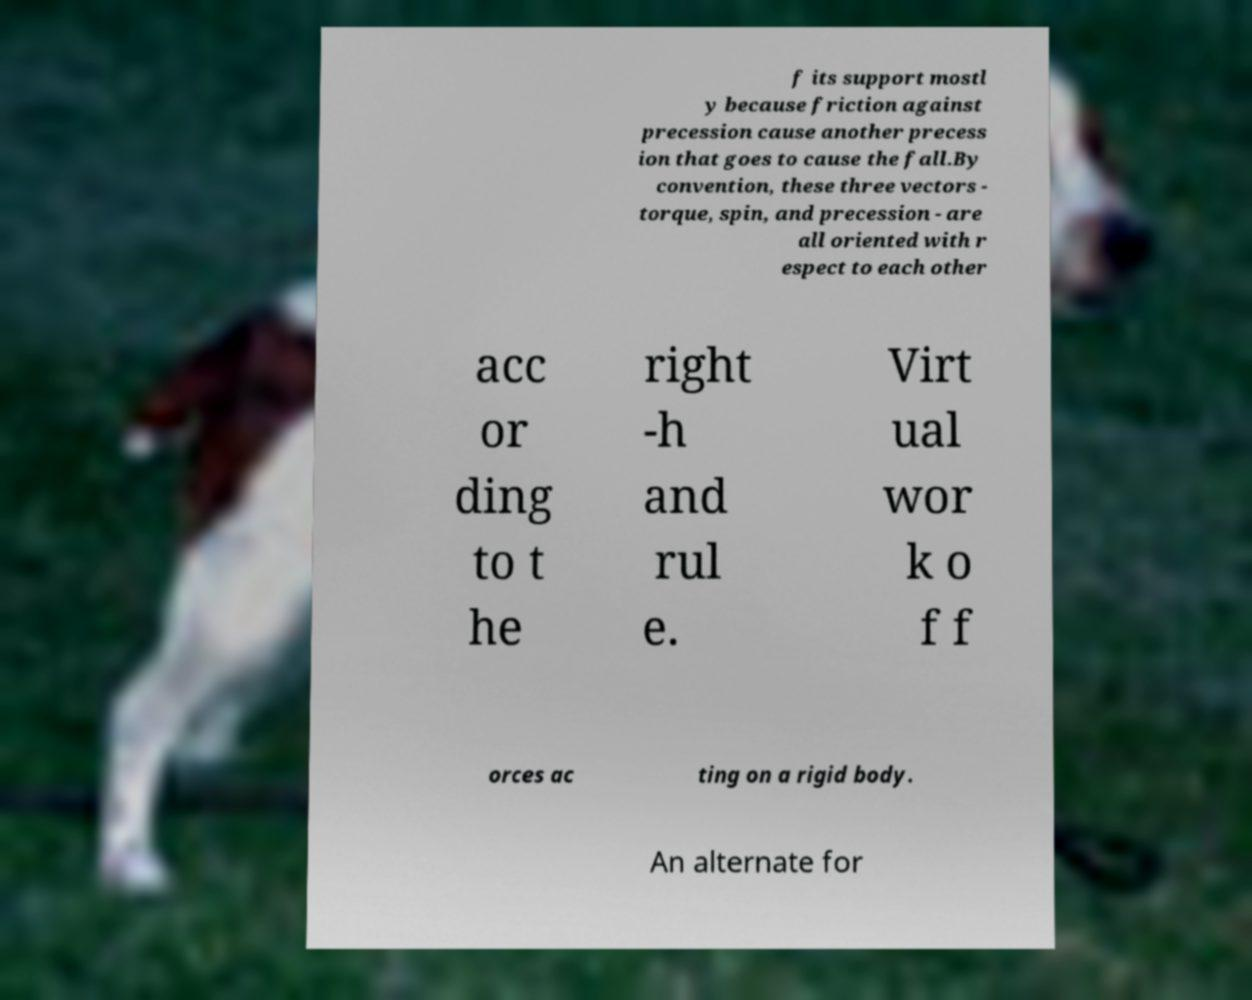Could you extract and type out the text from this image? f its support mostl y because friction against precession cause another precess ion that goes to cause the fall.By convention, these three vectors - torque, spin, and precession - are all oriented with r espect to each other acc or ding to t he right -h and rul e. Virt ual wor k o f f orces ac ting on a rigid body. An alternate for 